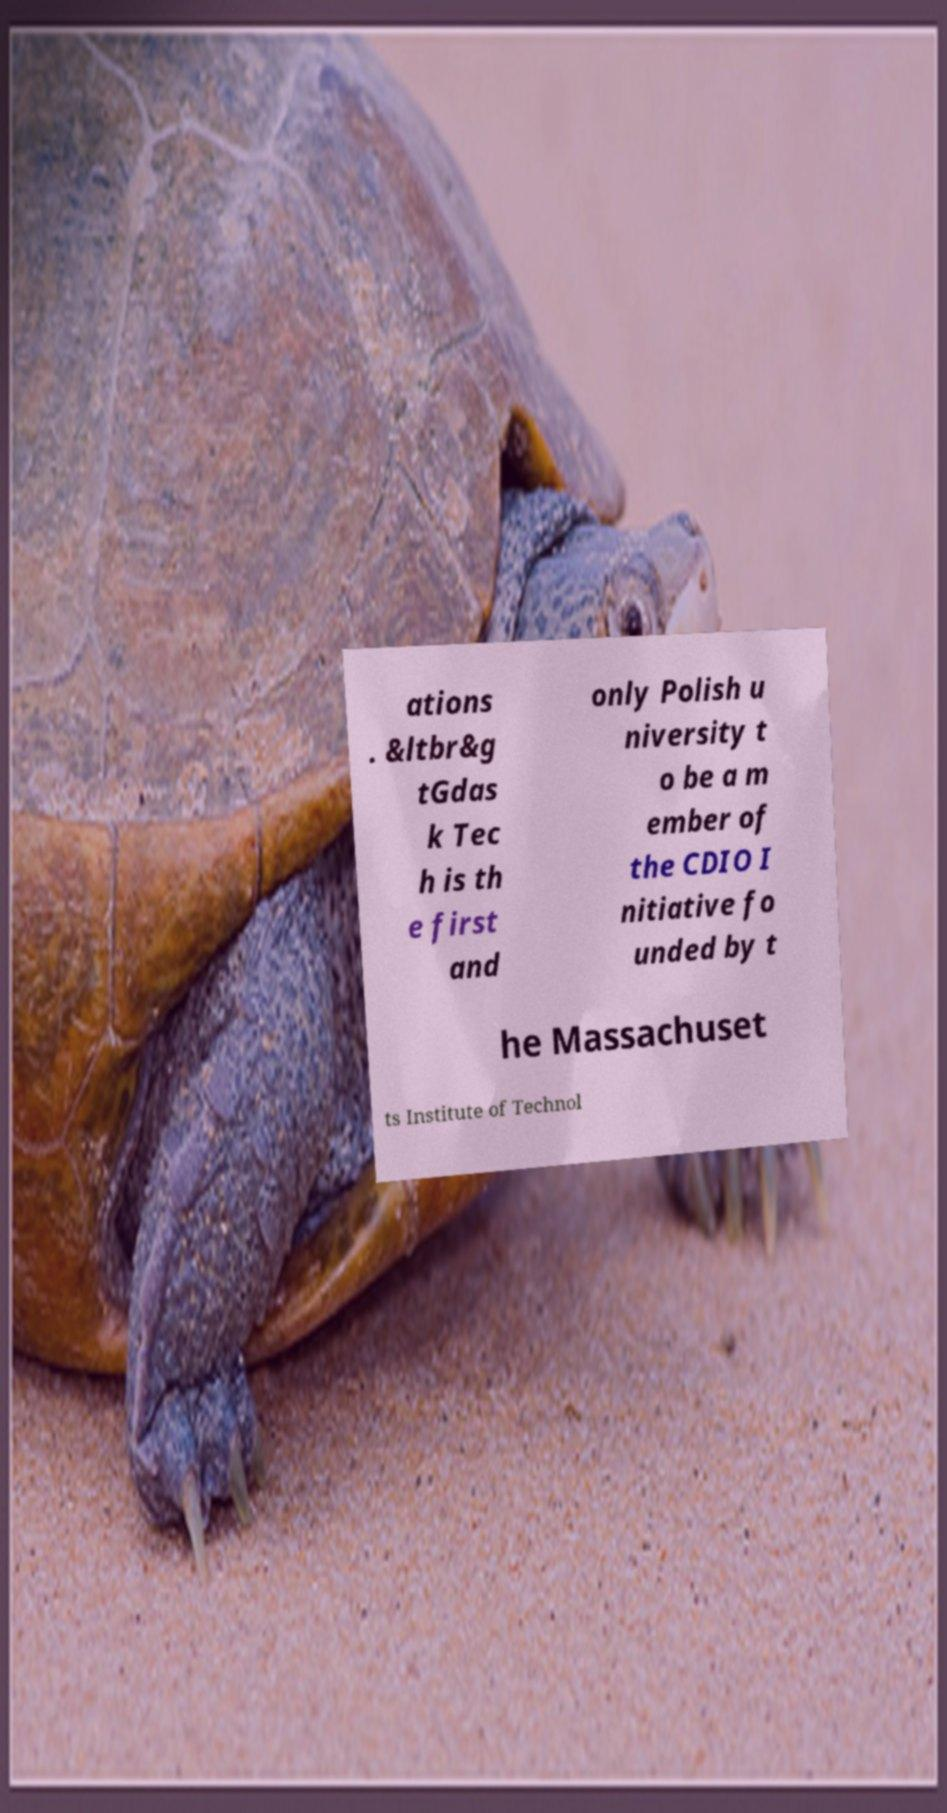Please read and relay the text visible in this image. What does it say? ations . &ltbr&g tGdas k Tec h is th e first and only Polish u niversity t o be a m ember of the CDIO I nitiative fo unded by t he Massachuset ts Institute of Technol 